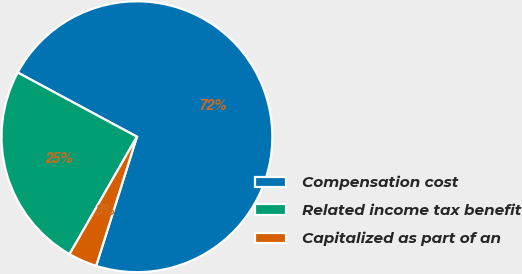<chart> <loc_0><loc_0><loc_500><loc_500><pie_chart><fcel>Compensation cost<fcel>Related income tax benefit<fcel>Capitalized as part of an<nl><fcel>72.01%<fcel>24.57%<fcel>3.42%<nl></chart> 